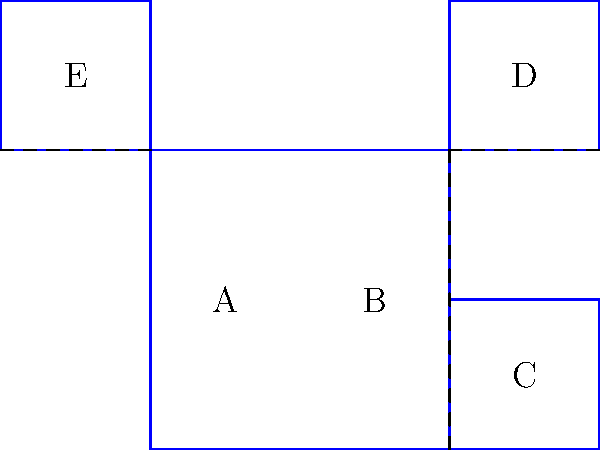In your experience organizing community events, you often need to create decorative boxes. Consider the flat pattern shown on the left. If you were to fold this pattern along the dashed lines, which 3D shape would it form? Is it similar to the cube shown on the right? Let's analyze this step-by-step:

1. Observe the flat pattern:
   - It consists of 5 squares labeled A, B, C, D, and E.
   - The dashed lines indicate where to fold.

2. Mentally fold the pattern:
   - Fold square C up 90 degrees along the right edge of B.
   - Fold square D up 90 degrees along the top edge of B.
   - Fold square E up 90 degrees along the left edge of A.

3. Analyze the resulting shape:
   - The main body is formed by squares A and B, creating the base.
   - Squares C, D, and E form three sides of the cube.
   - There's an open space where the sixth face of a cube would be.

4. Compare with the cube on the right:
   - The folded shape has only 5 faces, while a cube has 6.
   - The top of the folded shape would be open.

5. Conclusion:
   - The folded shape is not a complete cube, but rather an open box or a cube missing its top face.
Answer: Open-top cube 